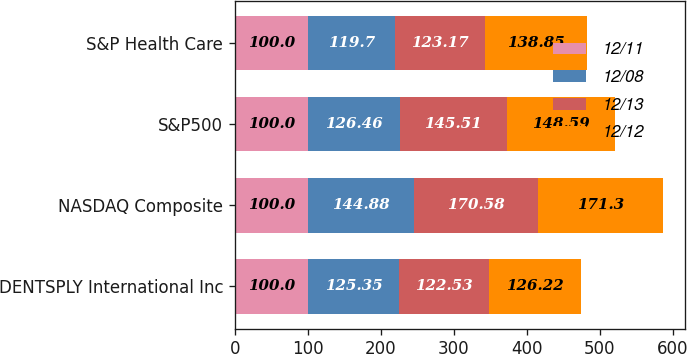<chart> <loc_0><loc_0><loc_500><loc_500><stacked_bar_chart><ecel><fcel>DENTSPLY International Inc<fcel>NASDAQ Composite<fcel>S&P500<fcel>S&P Health Care<nl><fcel>12/11<fcel>100<fcel>100<fcel>100<fcel>100<nl><fcel>12/08<fcel>125.35<fcel>144.88<fcel>126.46<fcel>119.7<nl><fcel>12/13<fcel>122.53<fcel>170.58<fcel>145.51<fcel>123.17<nl><fcel>12/12<fcel>126.22<fcel>171.3<fcel>148.59<fcel>138.85<nl></chart> 